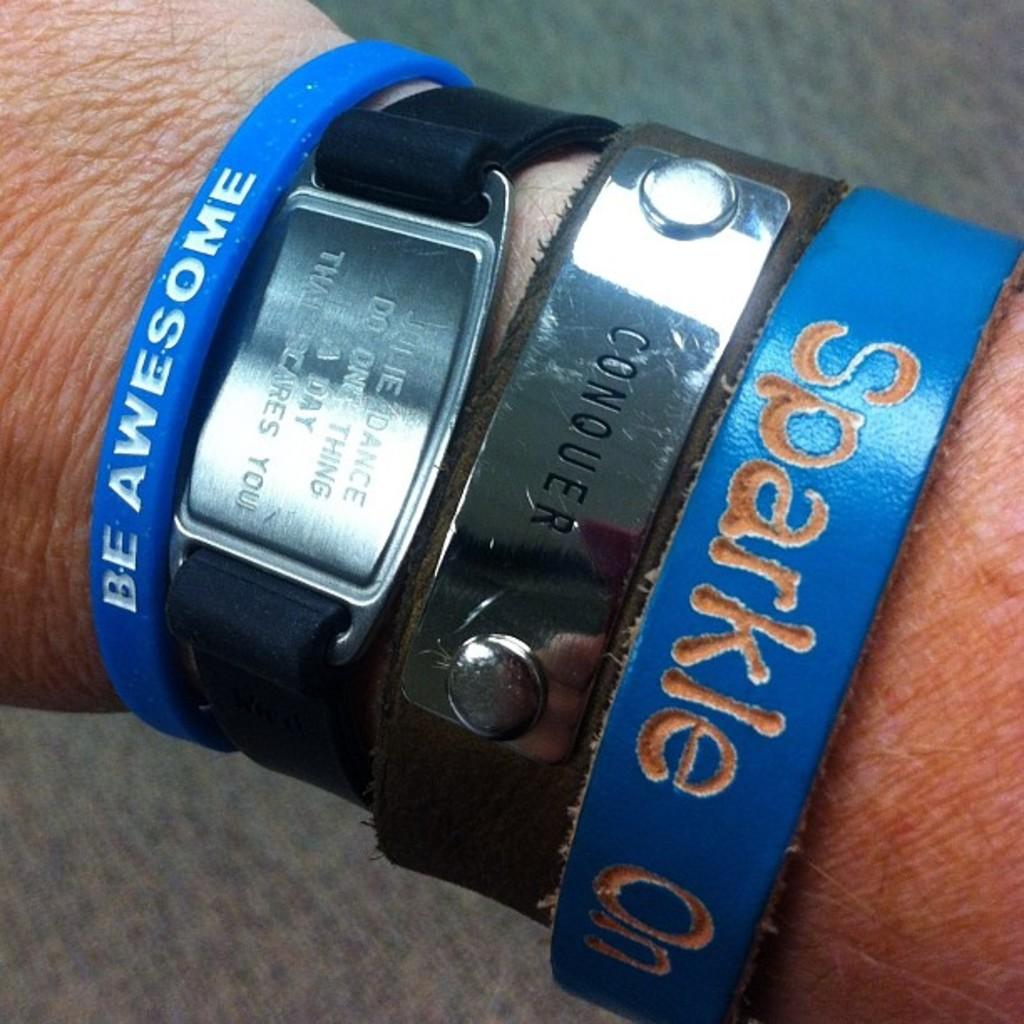<image>
Give a short and clear explanation of the subsequent image. Empowering statement bracelets saying sparkle on and be awesome. 